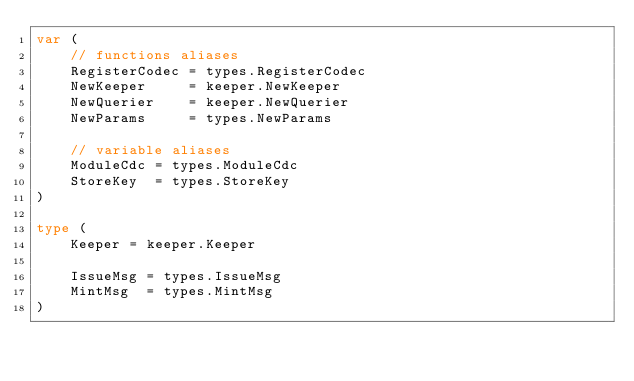<code> <loc_0><loc_0><loc_500><loc_500><_Go_>var (
	// functions aliases
	RegisterCodec = types.RegisterCodec
	NewKeeper     = keeper.NewKeeper
	NewQuerier    = keeper.NewQuerier
	NewParams     = types.NewParams

	// variable aliases
	ModuleCdc = types.ModuleCdc
	StoreKey  = types.StoreKey
)

type (
	Keeper = keeper.Keeper

	IssueMsg = types.IssueMsg
	MintMsg  = types.MintMsg
)
</code> 